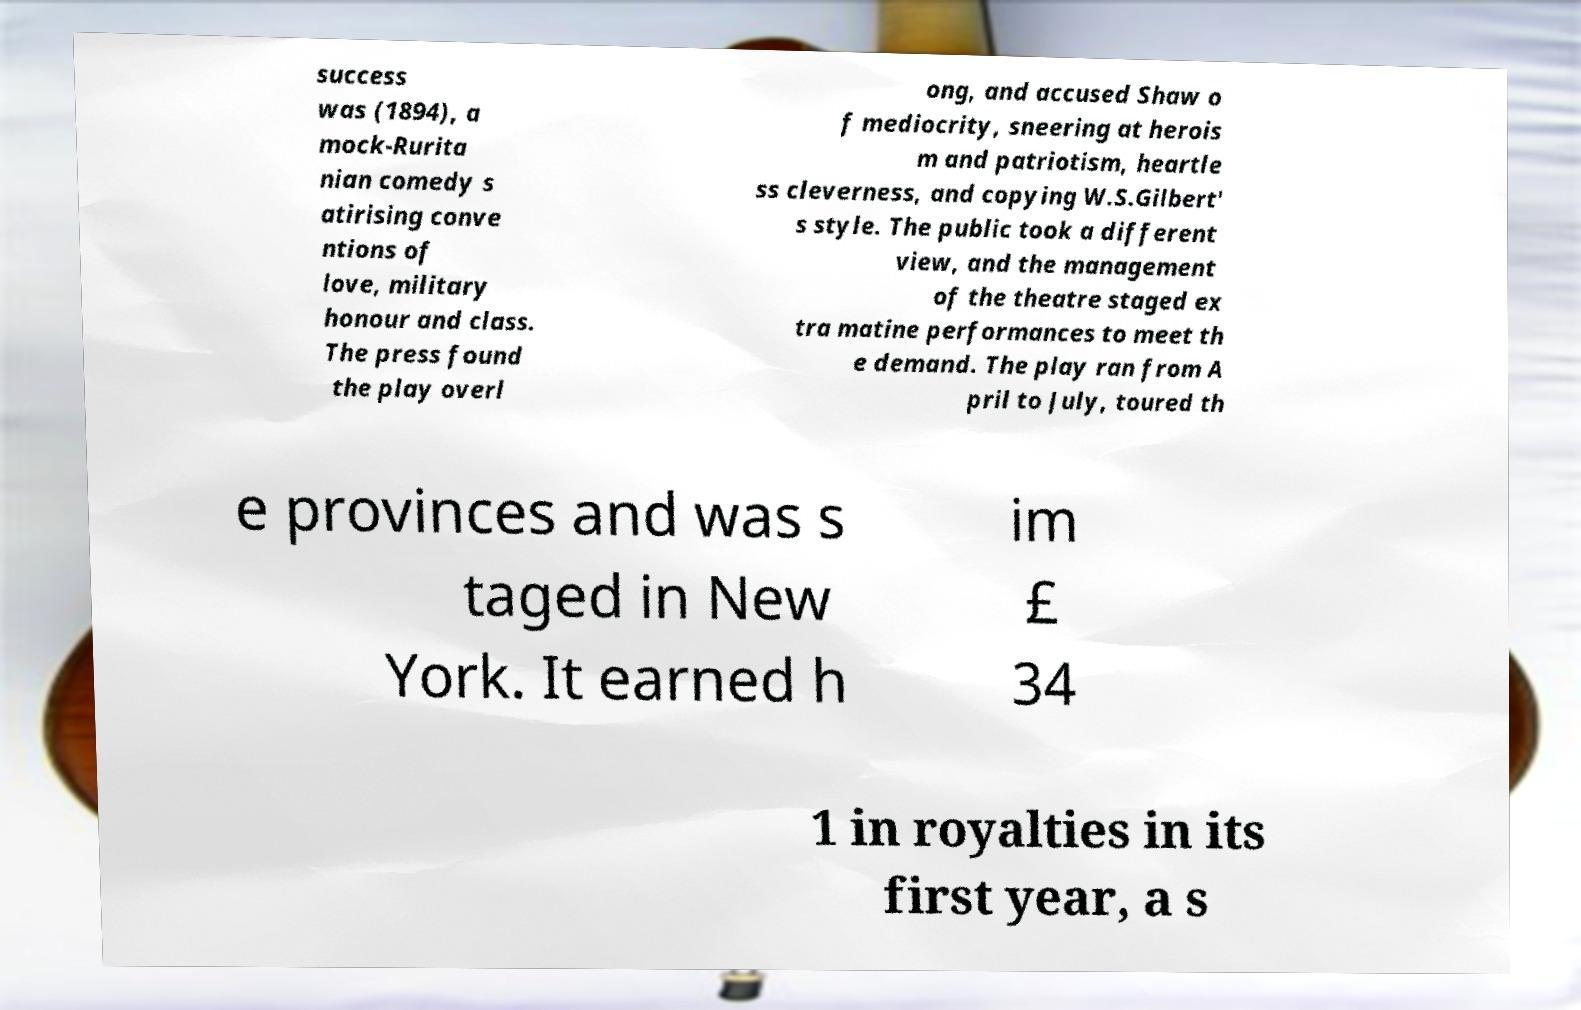Could you assist in decoding the text presented in this image and type it out clearly? success was (1894), a mock-Rurita nian comedy s atirising conve ntions of love, military honour and class. The press found the play overl ong, and accused Shaw o f mediocrity, sneering at herois m and patriotism, heartle ss cleverness, and copying W.S.Gilbert' s style. The public took a different view, and the management of the theatre staged ex tra matine performances to meet th e demand. The play ran from A pril to July, toured th e provinces and was s taged in New York. It earned h im £ 34 1 in royalties in its first year, a s 